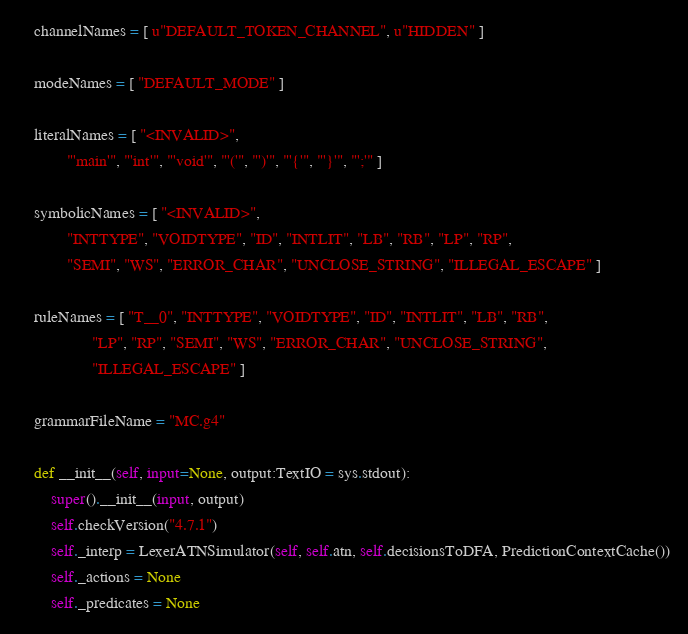<code> <loc_0><loc_0><loc_500><loc_500><_Python_>    channelNames = [ u"DEFAULT_TOKEN_CHANNEL", u"HIDDEN" ]

    modeNames = [ "DEFAULT_MODE" ]

    literalNames = [ "<INVALID>",
            "'main'", "'int'", "'void'", "'('", "')'", "'{'", "'}'", "';'" ]

    symbolicNames = [ "<INVALID>",
            "INTTYPE", "VOIDTYPE", "ID", "INTLIT", "LB", "RB", "LP", "RP", 
            "SEMI", "WS", "ERROR_CHAR", "UNCLOSE_STRING", "ILLEGAL_ESCAPE" ]

    ruleNames = [ "T__0", "INTTYPE", "VOIDTYPE", "ID", "INTLIT", "LB", "RB", 
                  "LP", "RP", "SEMI", "WS", "ERROR_CHAR", "UNCLOSE_STRING", 
                  "ILLEGAL_ESCAPE" ]

    grammarFileName = "MC.g4"

    def __init__(self, input=None, output:TextIO = sys.stdout):
        super().__init__(input, output)
        self.checkVersion("4.7.1")
        self._interp = LexerATNSimulator(self, self.atn, self.decisionsToDFA, PredictionContextCache())
        self._actions = None
        self._predicates = None


</code> 